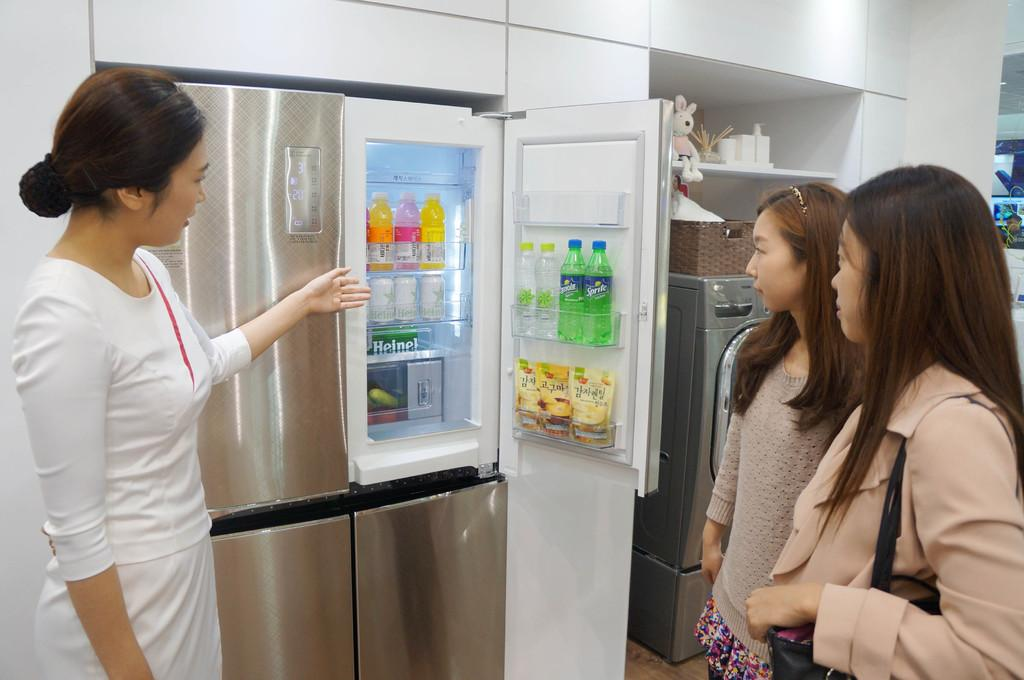Provide a one-sentence caption for the provided image. a seller showing a grey refrigerator,   with two sprite sodas on the door,  to two ladies. 